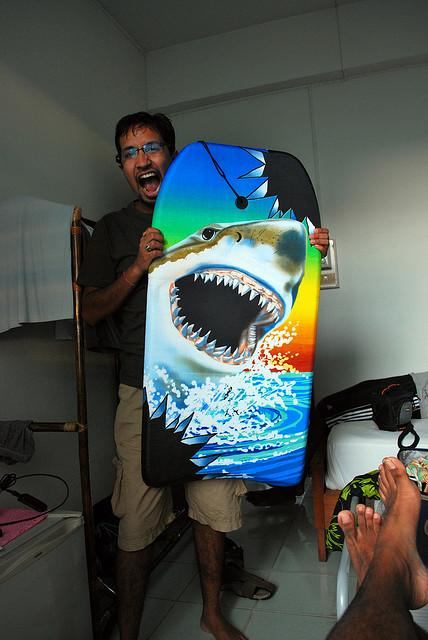What is the item being displayed by the man? surfboard 